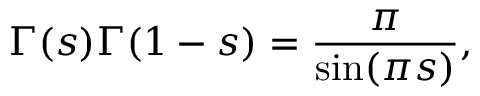<formula> <loc_0><loc_0><loc_500><loc_500>\Gamma ( s ) \Gamma ( 1 - s ) = { \frac { \pi } { \sin ( \pi s ) } } ,</formula> 